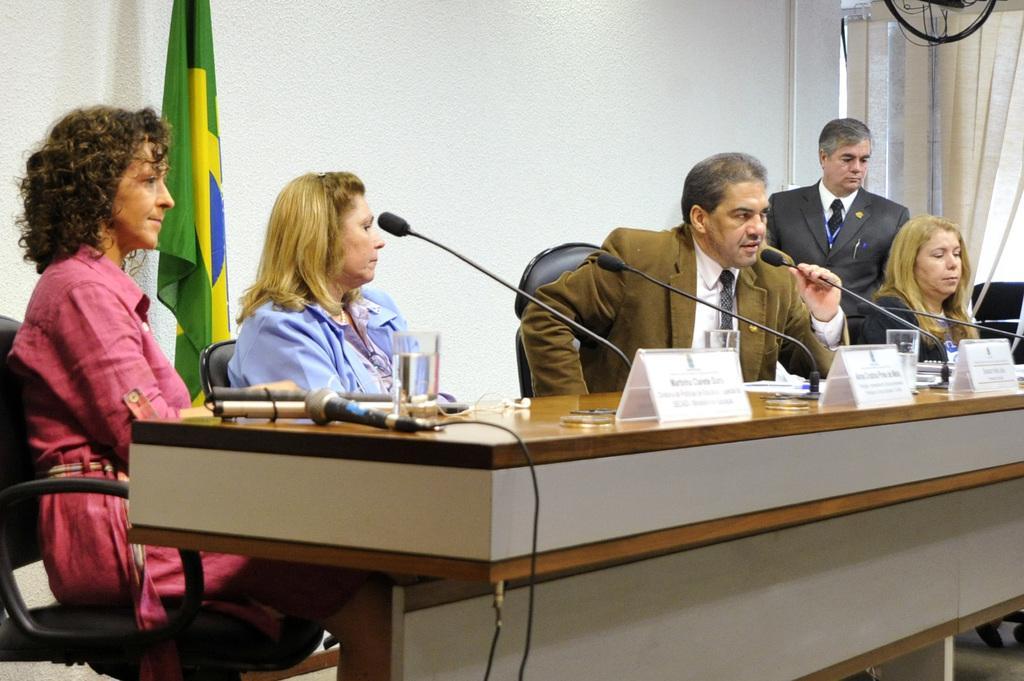Can you describe this image briefly? There are four persons sitting. This is a table with mike's,water glass,name boards placed on it. Here another person is standing. This is a flag hanging to the pole. This looks like a curtain. 